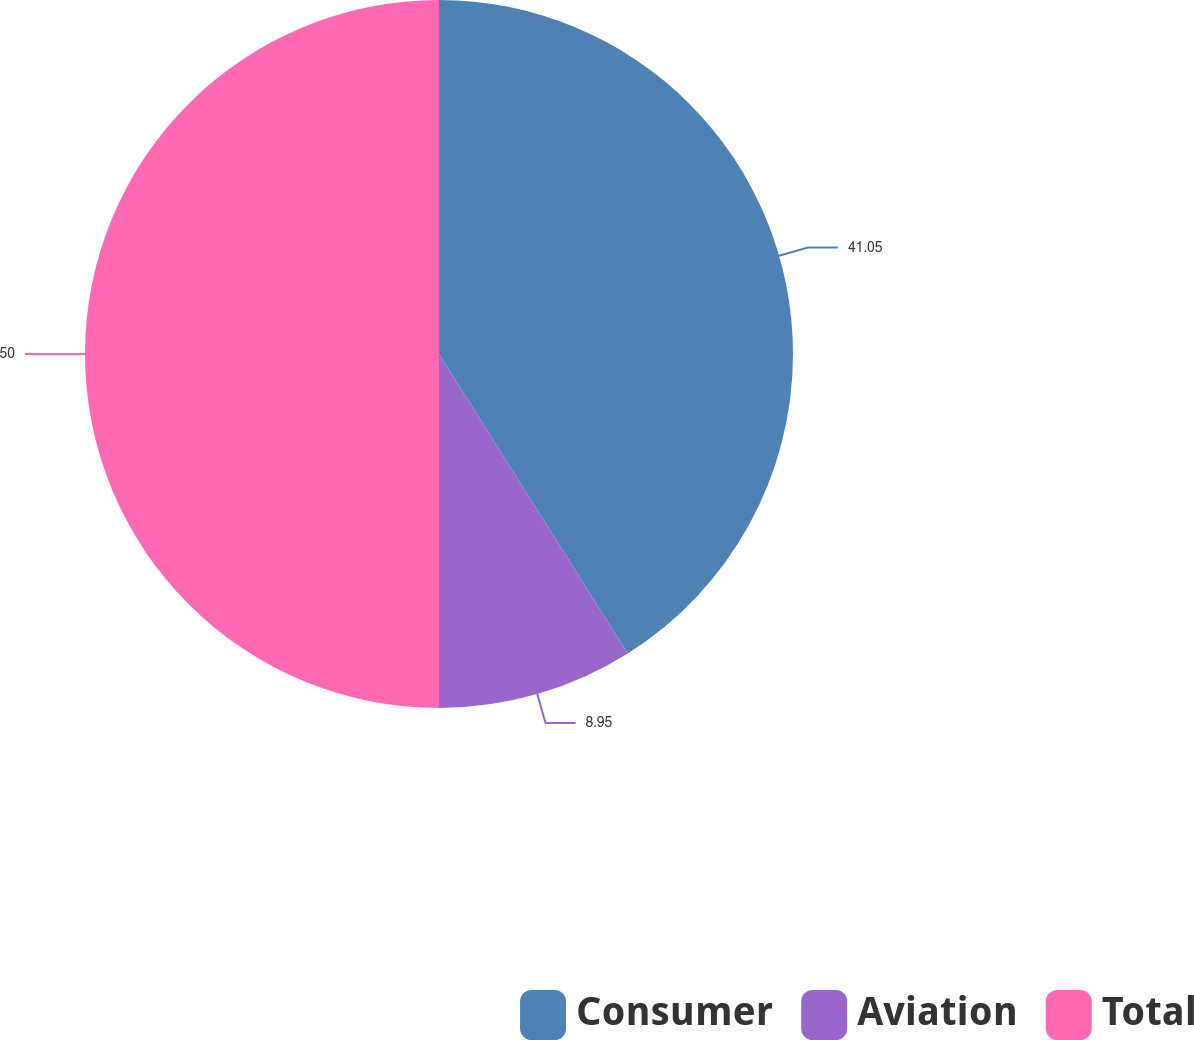Convert chart. <chart><loc_0><loc_0><loc_500><loc_500><pie_chart><fcel>Consumer<fcel>Aviation<fcel>Total<nl><fcel>41.05%<fcel>8.95%<fcel>50.0%<nl></chart> 